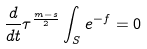<formula> <loc_0><loc_0><loc_500><loc_500>\frac { d } { d t } \tau ^ { \frac { m - s } { 2 } } \int _ { S } e ^ { - f } = 0</formula> 